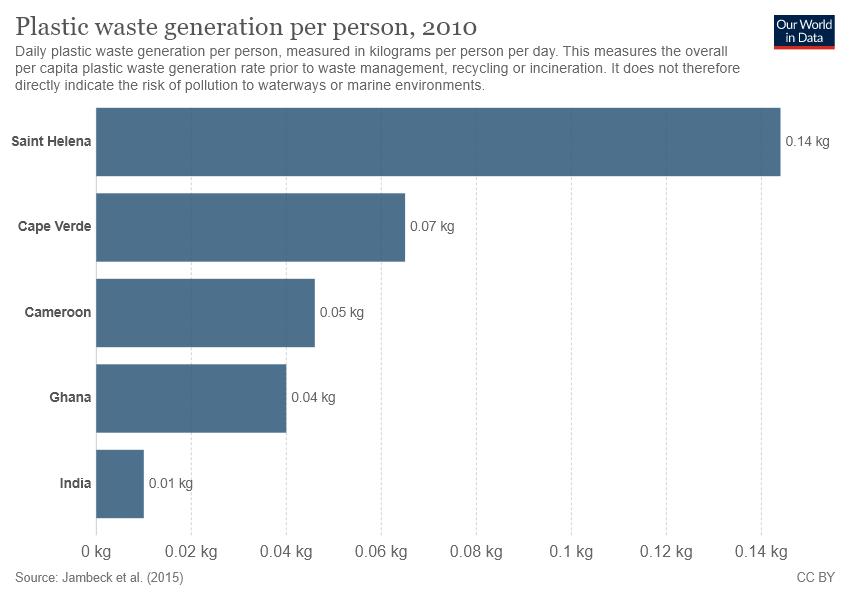Give some essential details in this illustration. The sum of all bars above 0.06kg is 0.21kg. With certainty, it can be declared that the color of all bars is blue. 